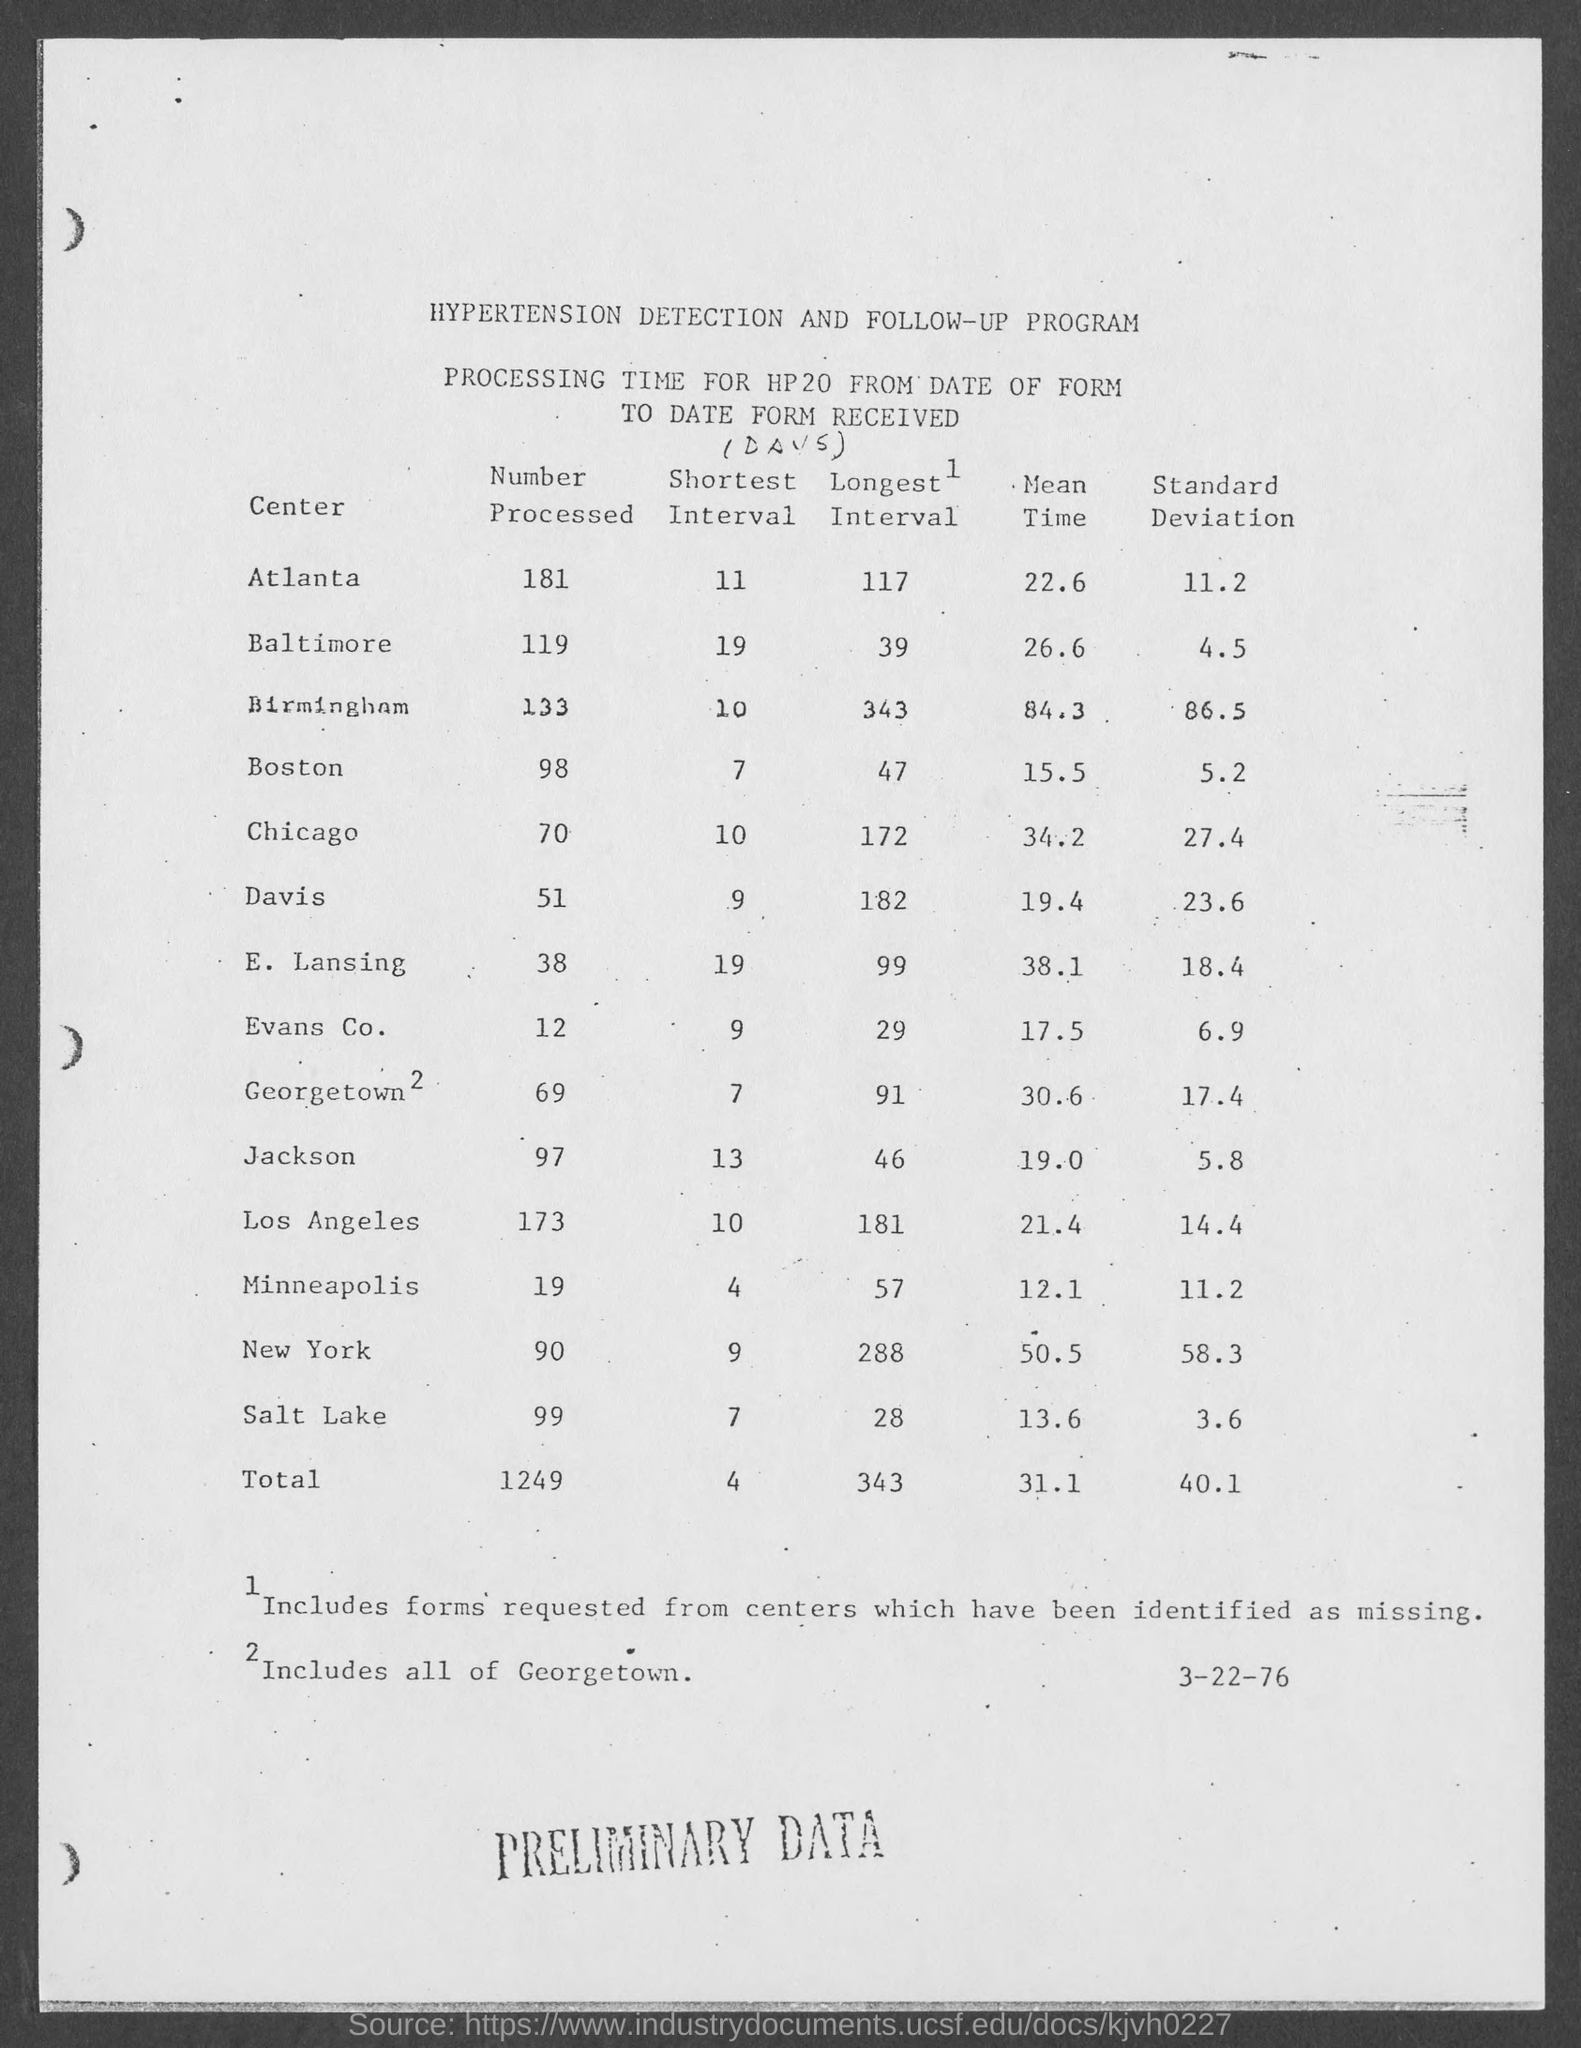What is the first center mentioned in the table?
Keep it short and to the point. Atlanta. What is the "Shortest Interval" for Atlanta in the table?
Offer a terse response. 11. What is the "Shortest Interval" for Baltimore in the table?
Keep it short and to the point. 19. What is the last column heading of the table?
Keep it short and to the point. Standard Deviation. What is the "Mean Time" for Boston in the table?
Give a very brief answer. 15.5. What is the "Standard Deviation" for Atlanta in the table?
Provide a short and direct response. 11.2. What is the Total Number Processed from all the centers?
Provide a short and direct response. 1249. What is the second center mentioned in the table ?
Make the answer very short. Baltimore. What is the last center mentioned in the table?
Make the answer very short. Salt Lake. What is the "Longest Interval" for Atlanta in the table ?
Your answer should be very brief. 117. 